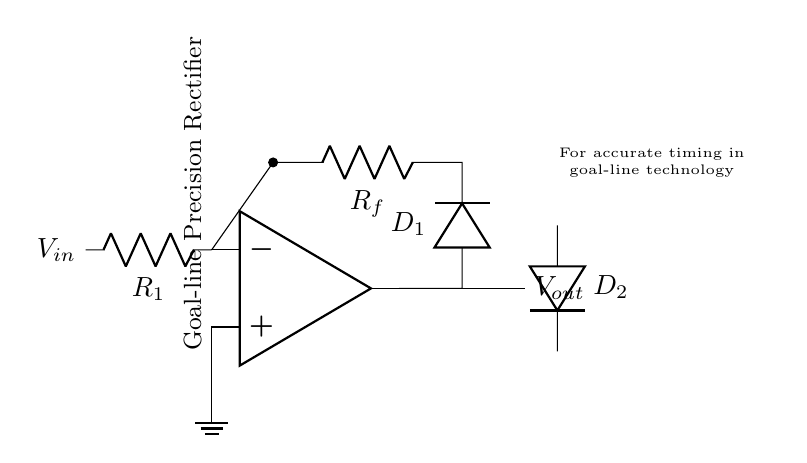What type of rectifier is shown in this circuit? This circuit is identified as a precision rectifier due to the presence of operational amplifiers and diodes configured to handle small input signals more accurately than conventional rectifiers.
Answer: Precision rectifier What is the function of the operational amplifier in this circuit? The operational amplifier amplifies the input signal and controls the flow of current through the diodes, allowing for precise rectification of the input voltage regardless of its small magnitude.
Answer: Amplification How many diodes are present in the circuit? The diagram shows two diodes, which are marked as D1 and D2, indicating there are two diodes in this precision rectifier setup.
Answer: Two What is the role of resistor R1 in the circuit? Resistor R1 sets the input resistance for the circuit, ensuring that the op-amp operates within its linear region and that signal integrity is maintained during rectification.
Answer: Input resistance Why is this circuit significant for goal-line technology? This circuit provides accurate voltage rectification, which is crucial for precisely determining the timing of goal-line events, ensuring that the technology can reliably register goals with high accuracy.
Answer: Accurate timing What happens to the output voltage when the input voltage is zero? When the input voltage is zero, the output voltage will also be zero because the operational amplifier will not activate the diodes, and there will be no voltage drop across R_f.
Answer: Zero volts What is the purpose of the feedback resistor R_f in the circuit? Resistor R_f is used for feedback in the op-amp configuration, which helps stabilize the circuit and sets the gain for accurate output voltage following rectification.
Answer: Stabilizes circuit 